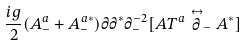Convert formula to latex. <formula><loc_0><loc_0><loc_500><loc_500>\frac { i g } { 2 } ( A _ { - } ^ { a } + A _ { - } ^ { a * } ) \partial \partial ^ { * } \partial _ { - } ^ { - 2 } [ A T ^ { a } \stackrel { \leftrightarrow } { \partial } _ { - } A ^ { * } ]</formula> 